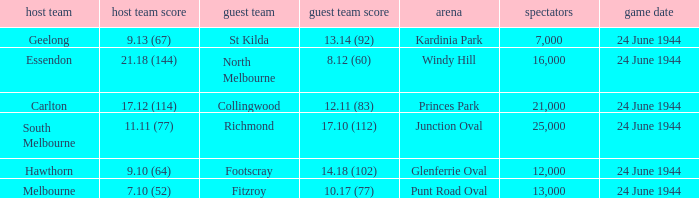When Essendon was the Home Team, what was the Away Team score? 8.12 (60). 